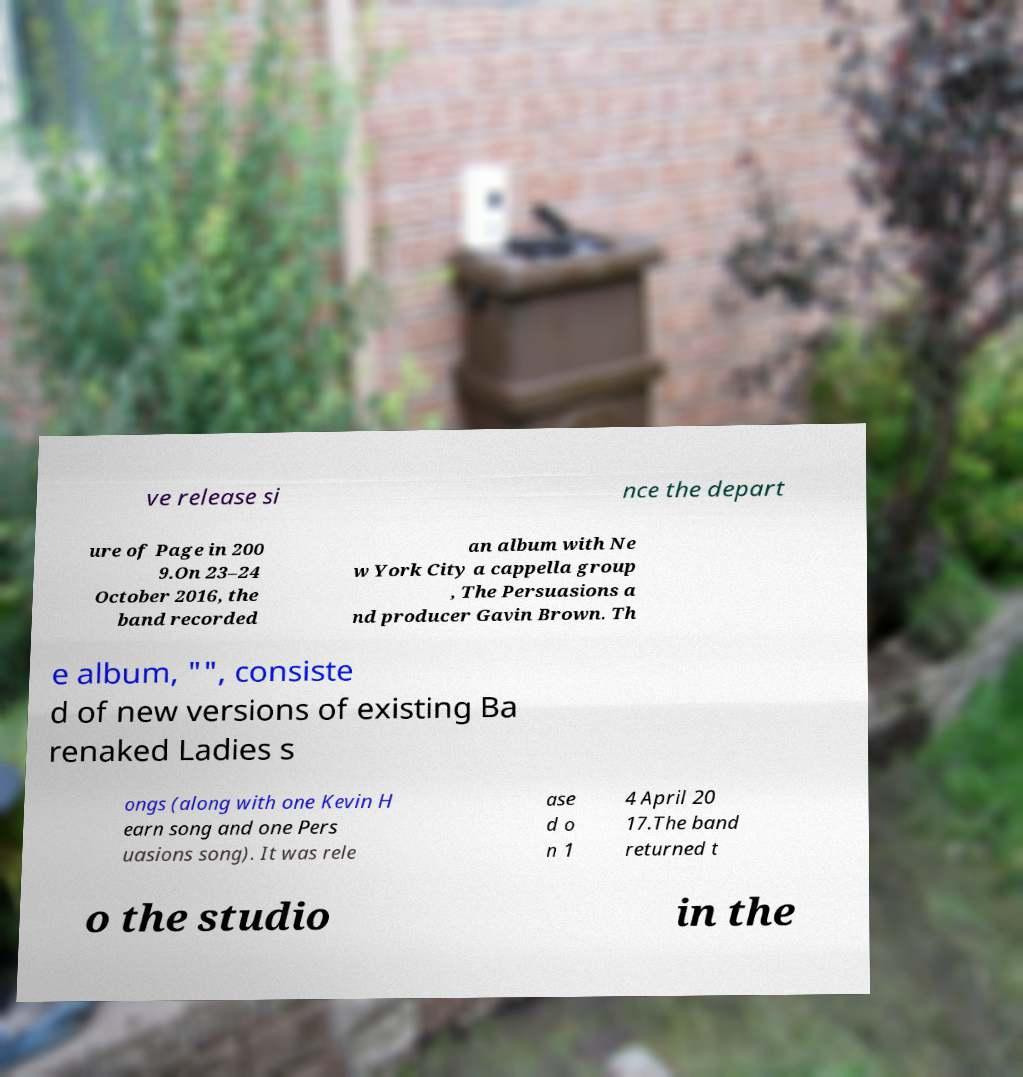Could you extract and type out the text from this image? ve release si nce the depart ure of Page in 200 9.On 23–24 October 2016, the band recorded an album with Ne w York City a cappella group , The Persuasions a nd producer Gavin Brown. Th e album, "", consiste d of new versions of existing Ba renaked Ladies s ongs (along with one Kevin H earn song and one Pers uasions song). It was rele ase d o n 1 4 April 20 17.The band returned t o the studio in the 